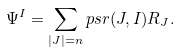Convert formula to latex. <formula><loc_0><loc_0><loc_500><loc_500>\Psi ^ { I } = \sum _ { | J | = n } p s r ( J , I ) R _ { J } .</formula> 